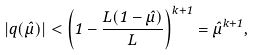<formula> <loc_0><loc_0><loc_500><loc_500>| q ( \hat { \mu } ) | < \left ( 1 - \frac { L ( 1 - \hat { \mu } ) } { L } \right ) ^ { k + 1 } = \hat { \mu } ^ { k + 1 } ,</formula> 